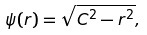Convert formula to latex. <formula><loc_0><loc_0><loc_500><loc_500>\psi ( r ) = \sqrt { C ^ { 2 } - r ^ { 2 } } ,</formula> 